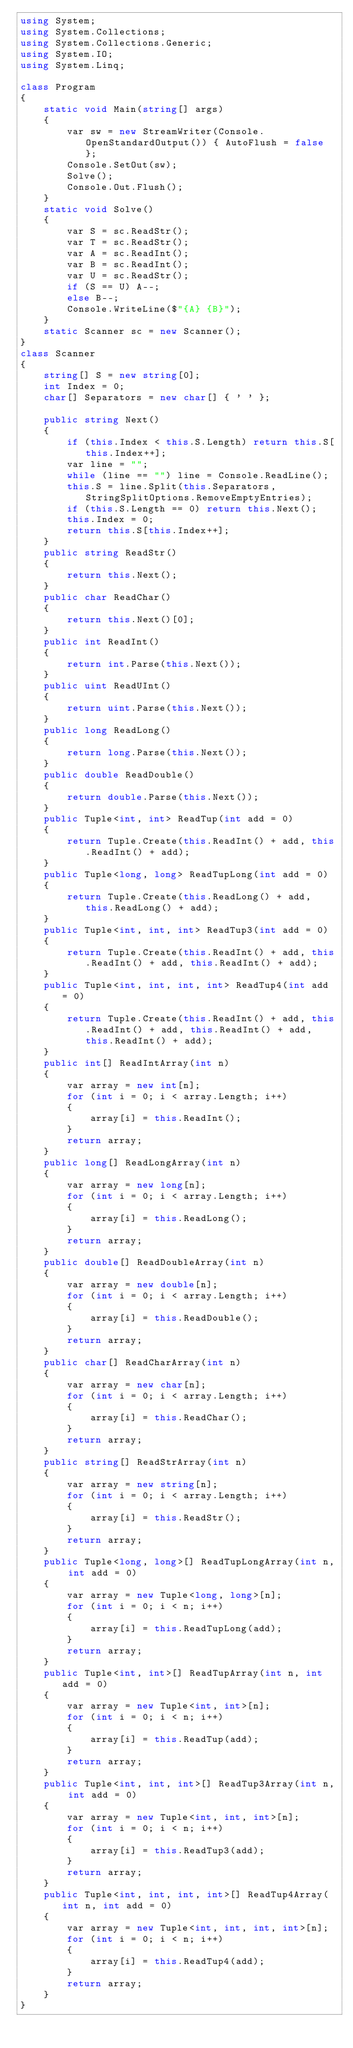Convert code to text. <code><loc_0><loc_0><loc_500><loc_500><_C#_>using System;
using System.Collections;
using System.Collections.Generic;
using System.IO;
using System.Linq;

class Program
{
    static void Main(string[] args)
    {
        var sw = new StreamWriter(Console.OpenStandardOutput()) { AutoFlush = false };
        Console.SetOut(sw);
        Solve();
        Console.Out.Flush();
    }
    static void Solve()
    {
        var S = sc.ReadStr();
        var T = sc.ReadStr();
        var A = sc.ReadInt();
        var B = sc.ReadInt();
        var U = sc.ReadStr();
        if (S == U) A--;
        else B--;
        Console.WriteLine($"{A} {B}");
    }
    static Scanner sc = new Scanner();
}
class Scanner
{
    string[] S = new string[0];
    int Index = 0;
    char[] Separators = new char[] { ' ' };

    public string Next()
    {
        if (this.Index < this.S.Length) return this.S[this.Index++];
        var line = "";
        while (line == "") line = Console.ReadLine();
        this.S = line.Split(this.Separators, StringSplitOptions.RemoveEmptyEntries);
        if (this.S.Length == 0) return this.Next();
        this.Index = 0;
        return this.S[this.Index++];
    }
    public string ReadStr()
    {
        return this.Next();
    }
    public char ReadChar()
    {
        return this.Next()[0];
    }
    public int ReadInt()
    {
        return int.Parse(this.Next());
    }
    public uint ReadUInt()
    {
        return uint.Parse(this.Next());
    }
    public long ReadLong()
    {
        return long.Parse(this.Next());
    }
    public double ReadDouble()
    {
        return double.Parse(this.Next());
    }
    public Tuple<int, int> ReadTup(int add = 0)
    {
        return Tuple.Create(this.ReadInt() + add, this.ReadInt() + add);
    }
    public Tuple<long, long> ReadTupLong(int add = 0)
    {
        return Tuple.Create(this.ReadLong() + add, this.ReadLong() + add);
    }
    public Tuple<int, int, int> ReadTup3(int add = 0)
    {
        return Tuple.Create(this.ReadInt() + add, this.ReadInt() + add, this.ReadInt() + add);
    }
    public Tuple<int, int, int, int> ReadTup4(int add = 0)
    {
        return Tuple.Create(this.ReadInt() + add, this.ReadInt() + add, this.ReadInt() + add, this.ReadInt() + add);
    }
    public int[] ReadIntArray(int n)
    {
        var array = new int[n];
        for (int i = 0; i < array.Length; i++)
        {
            array[i] = this.ReadInt();
        }
        return array;
    }
    public long[] ReadLongArray(int n)
    {
        var array = new long[n];
        for (int i = 0; i < array.Length; i++)
        {
            array[i] = this.ReadLong();
        }
        return array;
    }
    public double[] ReadDoubleArray(int n)
    {
        var array = new double[n];
        for (int i = 0; i < array.Length; i++)
        {
            array[i] = this.ReadDouble();
        }
        return array;
    }
    public char[] ReadCharArray(int n)
    {
        var array = new char[n];
        for (int i = 0; i < array.Length; i++)
        {
            array[i] = this.ReadChar();
        }
        return array;
    }
    public string[] ReadStrArray(int n)
    {
        var array = new string[n];
        for (int i = 0; i < array.Length; i++)
        {
            array[i] = this.ReadStr();
        }
        return array;
    }
    public Tuple<long, long>[] ReadTupLongArray(int n, int add = 0)
    {
        var array = new Tuple<long, long>[n];
        for (int i = 0; i < n; i++)
        {
            array[i] = this.ReadTupLong(add);
        }
        return array;
    }
    public Tuple<int, int>[] ReadTupArray(int n, int add = 0)
    {
        var array = new Tuple<int, int>[n];
        for (int i = 0; i < n; i++)
        {
            array[i] = this.ReadTup(add);
        }
        return array;
    }
    public Tuple<int, int, int>[] ReadTup3Array(int n, int add = 0)
    {
        var array = new Tuple<int, int, int>[n];
        for (int i = 0; i < n; i++)
        {
            array[i] = this.ReadTup3(add);
        }
        return array;
    }
    public Tuple<int, int, int, int>[] ReadTup4Array(int n, int add = 0)
    {
        var array = new Tuple<int, int, int, int>[n];
        for (int i = 0; i < n; i++)
        {
            array[i] = this.ReadTup4(add);
        }
        return array;
    }
}
</code> 